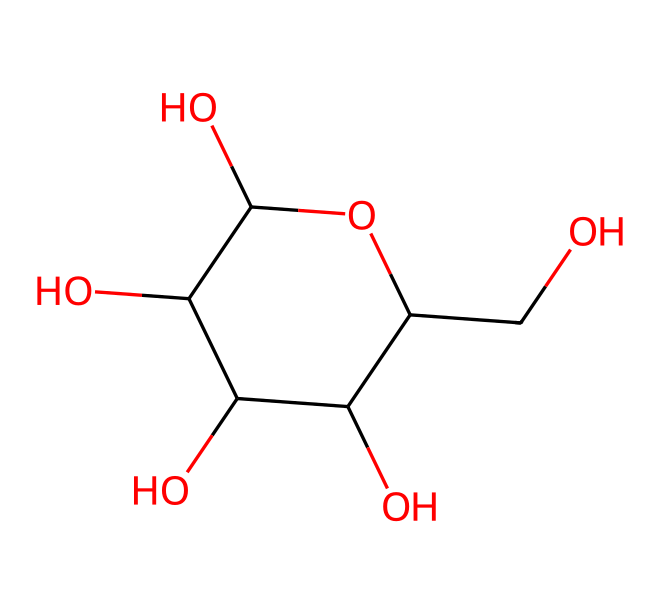What is the molecular formula of glucose? To determine the molecular formula, count the number of each type of atom present in the SMILES. There are 6 carbon (C) atoms, 12 hydrogen (H) atoms, and 6 oxygen (O) atoms which gives the molecular formula C6H12O6.
Answer: C6H12O6 How many hydroxyl groups are present in glucose? A hydroxyl group (-OH) is indicated by the -O plus a hydrogen atom in the structure. In glucose, there are 5 hydroxyl groups attached to the carbon atoms.
Answer: 5 What type of isomerism is exhibited by glucose? Glucose has multiple forms, including an aldehyde and a cyclic form. These forms create structural isomers due to the arrangement of the atoms in space, particularly in its cyclic form, glucose exhibits stereoisomerism.
Answer: stereoisomerism What would be the primary non-electrolyte classification of glucose? Glucose primarily functions as a non-electrolyte because it does not dissociate into ions in solution. Non-electrolytes are characterized by their inability to conduct electricity, which applies to glucose, making it classified as such.
Answer: non-electrolyte How many rings does the structure of glucose have? The SMILES representation indicates that glucose has a cyclic structure with one ring formed by carbon atoms connected through single bonds and hydroxyl groups, thus it has one ring.
Answer: 1 How does the structure of glucose facilitate its role as an energy source? Glucose has multiple hydroxyl groups that can participate in hydrogen bonding, making it soluble in water. Its structure allows for easy metabolism and quick energy release, as its bonds can be broken down readily.
Answer: metabolism 